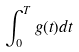Convert formula to latex. <formula><loc_0><loc_0><loc_500><loc_500>\int _ { 0 } ^ { T } g ( t ) d t</formula> 